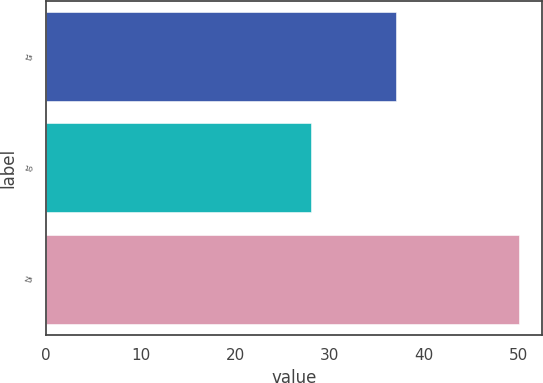Convert chart. <chart><loc_0><loc_0><loc_500><loc_500><bar_chart><fcel>15<fcel>10<fcel>25<nl><fcel>37<fcel>28<fcel>50<nl></chart> 